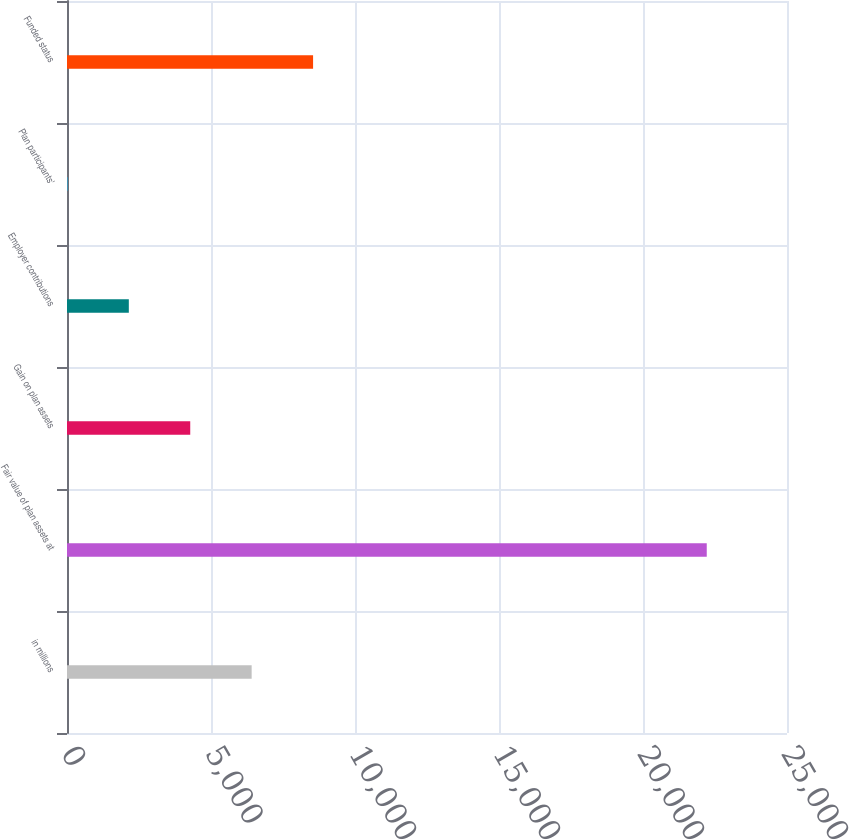<chart> <loc_0><loc_0><loc_500><loc_500><bar_chart><fcel>in millions<fcel>Fair value of plan assets at<fcel>Gain on plan assets<fcel>Employer contributions<fcel>Plan participants'<fcel>Funded status<nl><fcel>6411.8<fcel>22213.6<fcel>4279.2<fcel>2146.6<fcel>14<fcel>8544.4<nl></chart> 